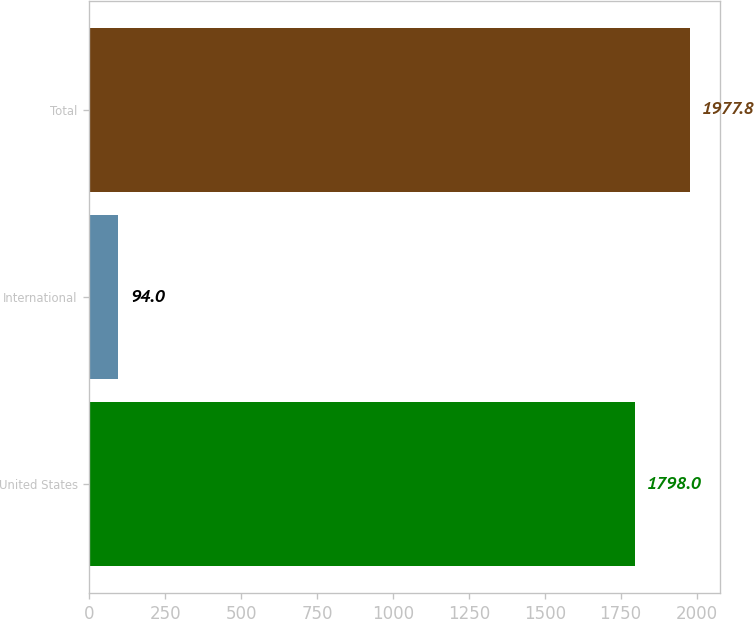Convert chart to OTSL. <chart><loc_0><loc_0><loc_500><loc_500><bar_chart><fcel>United States<fcel>International<fcel>Total<nl><fcel>1798<fcel>94<fcel>1977.8<nl></chart> 